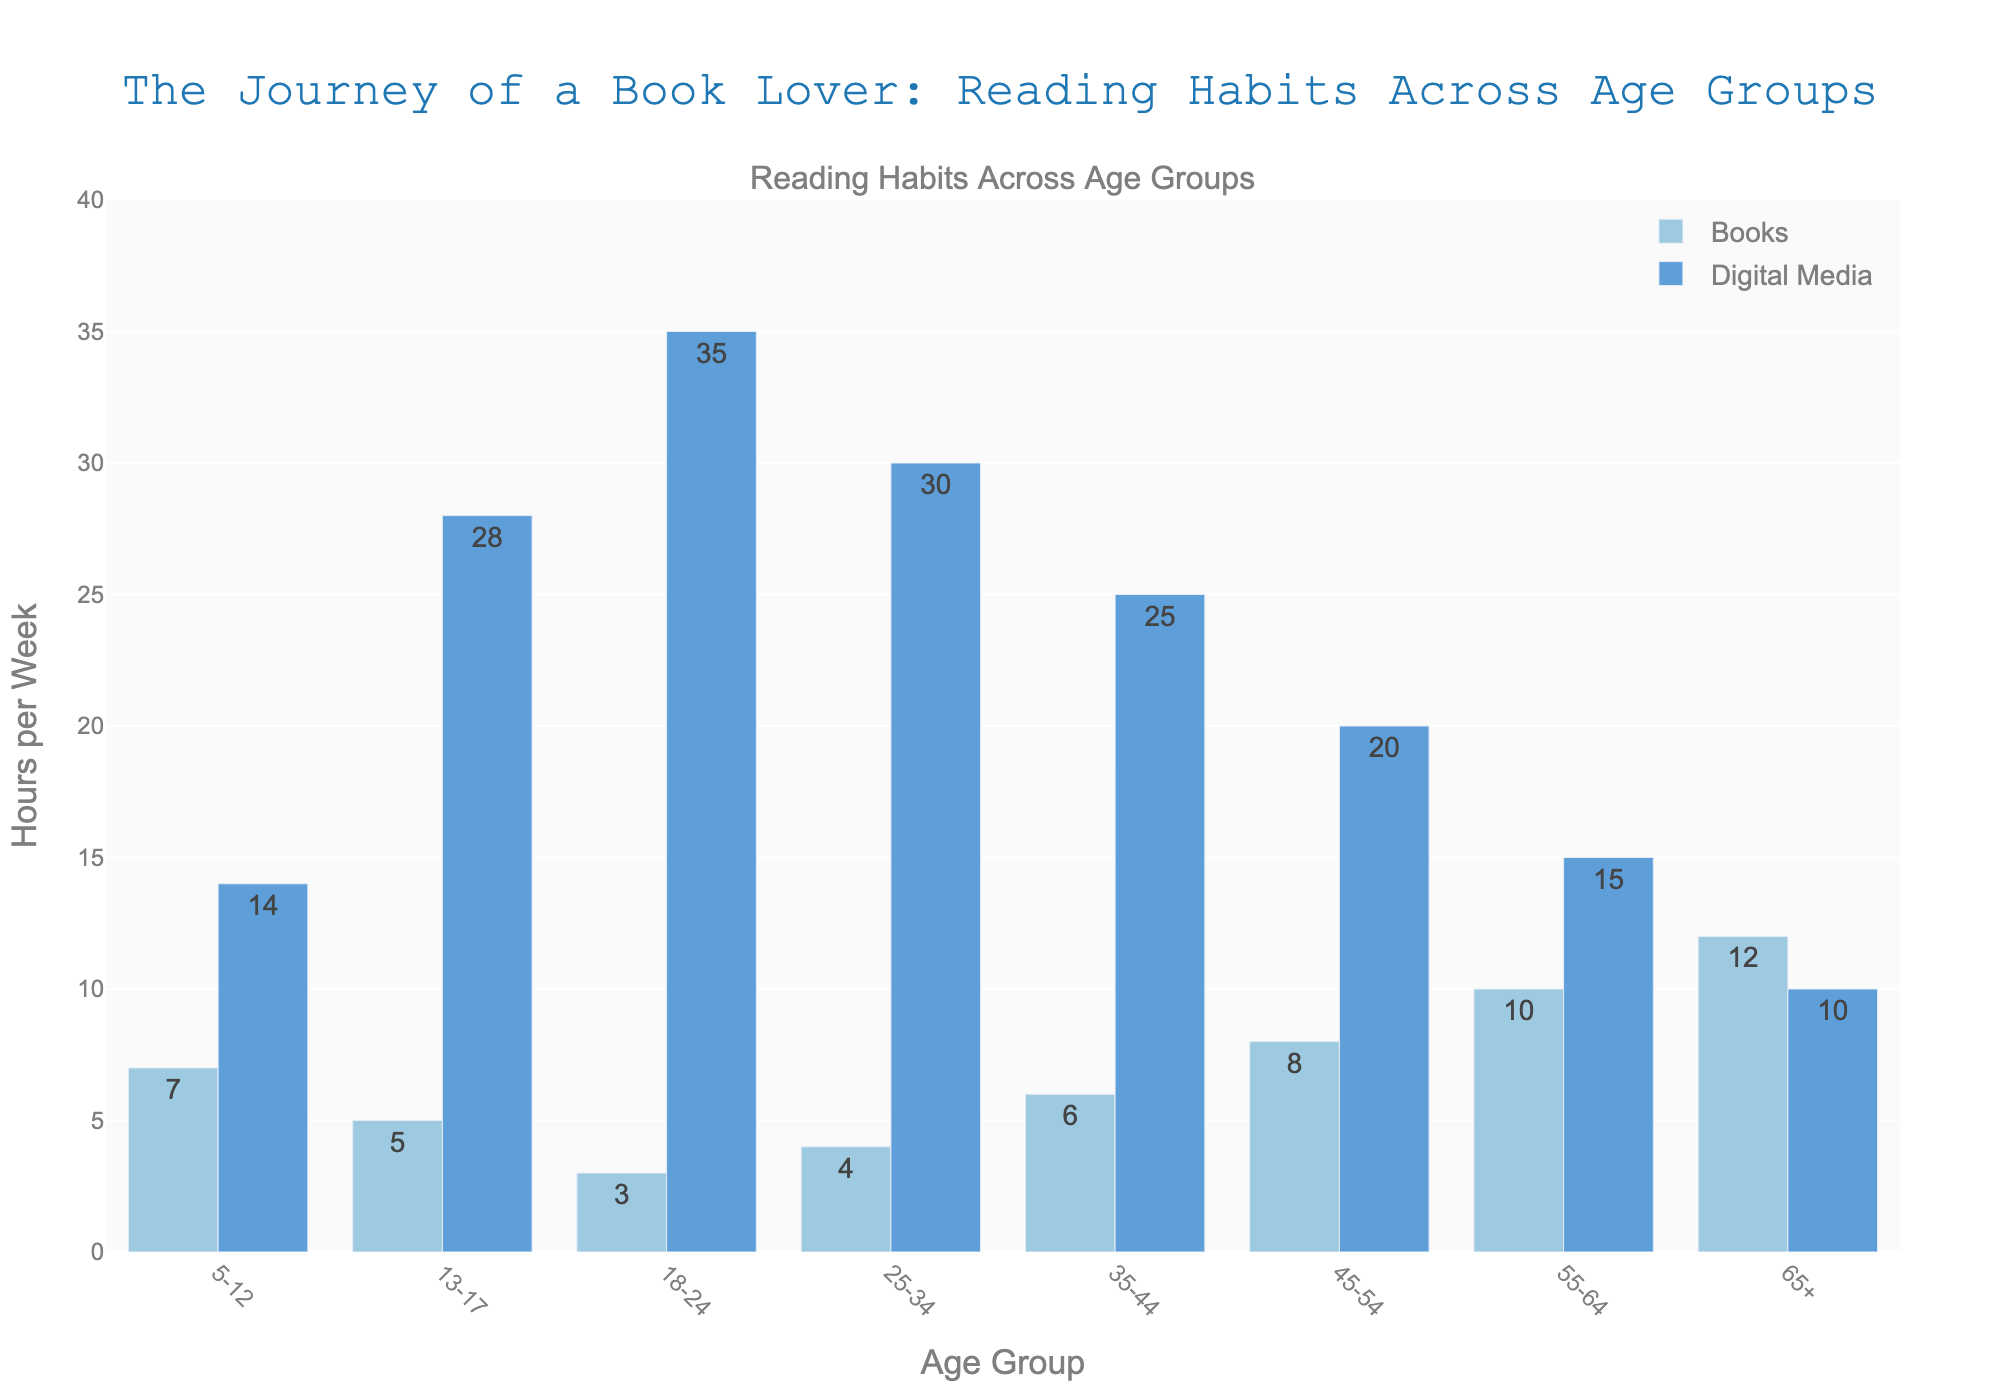What age group spends the most time reading books per week? The age group 65+ has the highest bar for hours spent on books, indicating this group reads the most.
Answer: 65+ Which age group spends the most time on digital media per week? The age group 18-24 has the highest bar for hours spent on digital media, indicating this group uses digital media the most.
Answer: 18-24 What's the difference in hours spent on digital media between the age groups 5-12 and 13-17? The bar for 5-12 shows 14 hours and for 13-17 shows 28 hours. Subtracting 14 from 28 gives the difference.
Answer: 14 How much more time do the 18-24 age group spend on digital media compared to reading books? The bar for digital media in 18-24 indicates 35 hours, and the bar for books indicates 3 hours. Subtracting 3 from 35 gives the difference.
Answer: 32 Which age group has the smallest difference between hours spent on books and hours spent on digital media? By visually comparing the heights of the two bars for each age group, the 65+ group has the smallest difference (12 hours on books and 10 hours on digital media).
Answer: 65+ How does the hours spent on digital media by the 35-44 age group compare to the 25-34 age group? The bar for 35-44 shows 25 hours and for 25-34 shows 30 hours, indicating the 35-44 age group spends 5 fewer hours on digital media.
Answer: 35-44 spends 5 fewer hours What is the total time spent on books per week by all age groups combined? Summing the heights of the bars for books: 7+5+3+4+6+8+10+12 = 55
Answer: 55 hours Which age group spends equal time on books and digital media combined? By adding the hours for books and digital media for each age group, the 13-17 age group spends 33 hours total (5 hours on books + 28 hours on digital media), and no other age group matches this pattern of equality.
Answer: None What is the average time spent on digital media by age groups 45-54 and 55-64? The bar for 45-54 shows 20 hours, and the bar for 55-64 shows 15 hours. Summing these values gives 35, and dividing by 2 provides the average.
Answer: 17.5 hours Which age group's digital media usage is represented by a bar twice as tall as their book reading bar? For the 5-12 age group, the bar for digital media is twice as tall as the bar for books (14 hours vs. 7 hours).
Answer: 5-12 